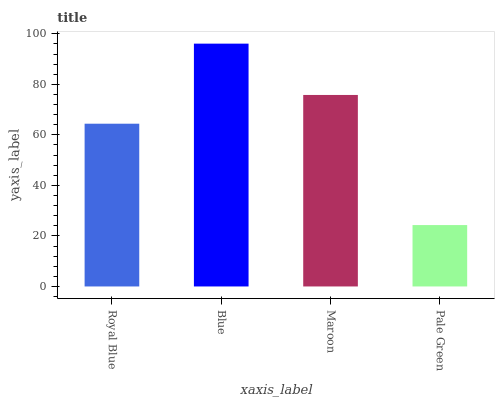Is Pale Green the minimum?
Answer yes or no. Yes. Is Blue the maximum?
Answer yes or no. Yes. Is Maroon the minimum?
Answer yes or no. No. Is Maroon the maximum?
Answer yes or no. No. Is Blue greater than Maroon?
Answer yes or no. Yes. Is Maroon less than Blue?
Answer yes or no. Yes. Is Maroon greater than Blue?
Answer yes or no. No. Is Blue less than Maroon?
Answer yes or no. No. Is Maroon the high median?
Answer yes or no. Yes. Is Royal Blue the low median?
Answer yes or no. Yes. Is Blue the high median?
Answer yes or no. No. Is Blue the low median?
Answer yes or no. No. 